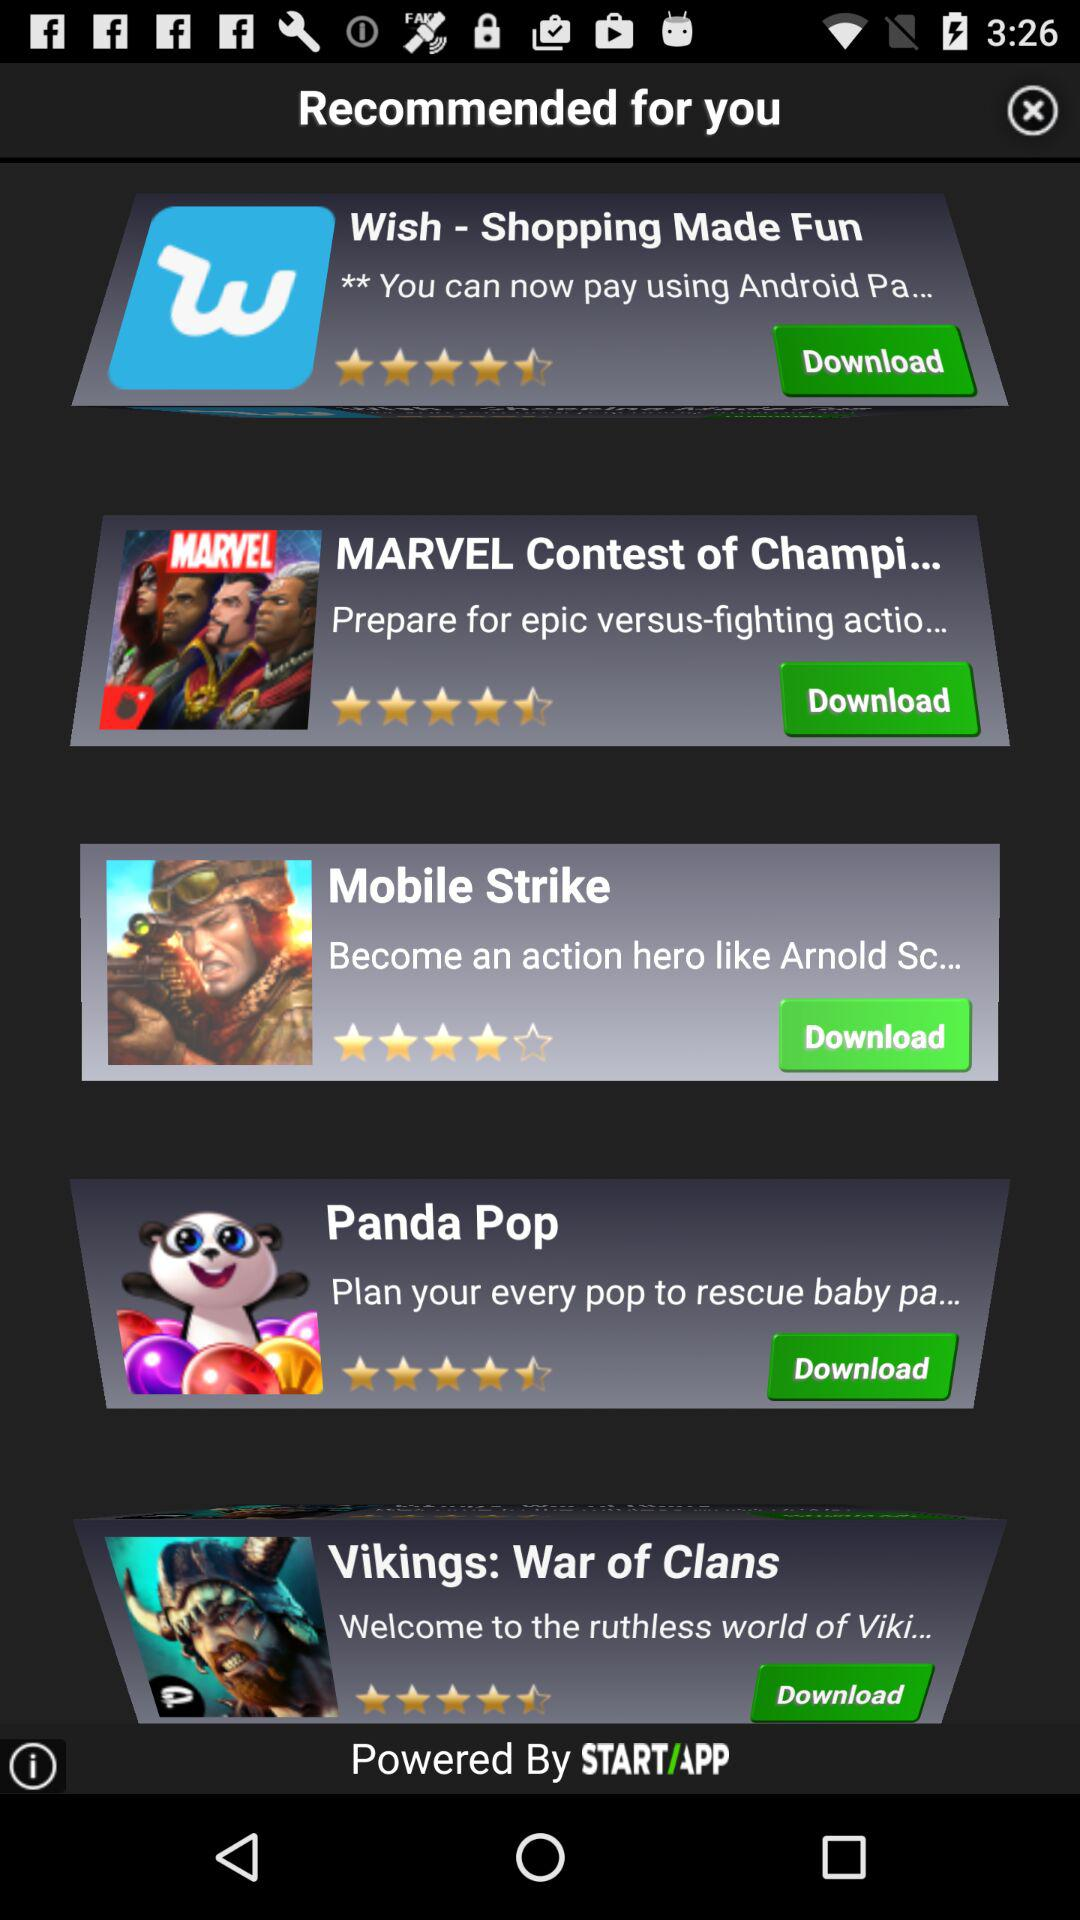What is the star rating of the application "Mobile Strike"? The rating is 4 stars. 